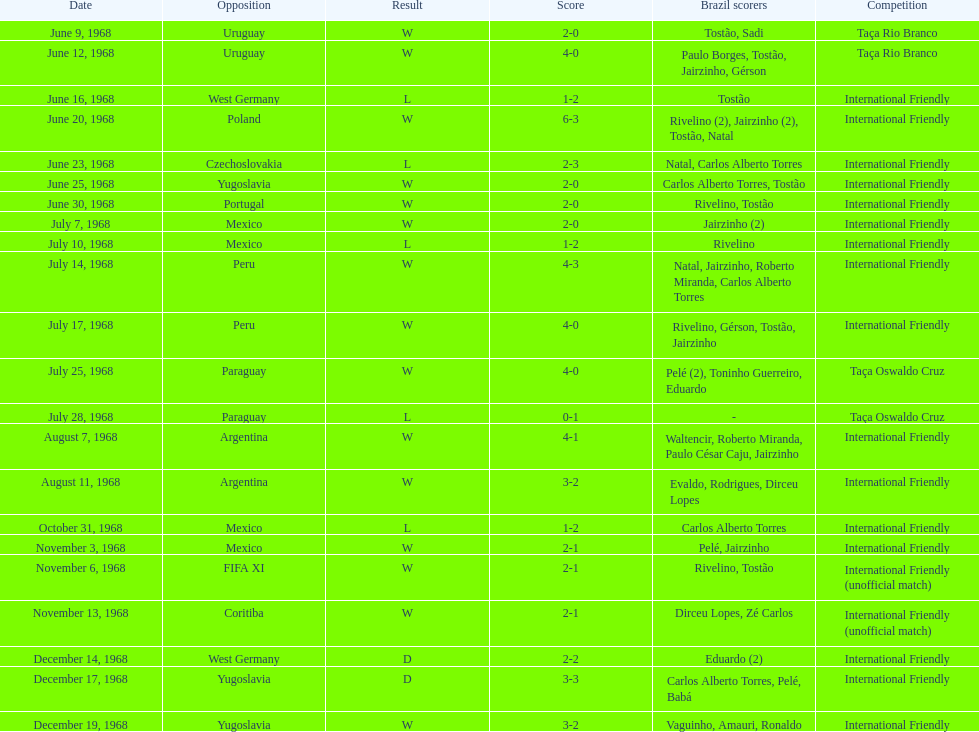Parse the table in full. {'header': ['Date', 'Opposition', 'Result', 'Score', 'Brazil scorers', 'Competition'], 'rows': [['June 9, 1968', 'Uruguay', 'W', '2-0', 'Tostão, Sadi', 'Taça Rio Branco'], ['June 12, 1968', 'Uruguay', 'W', '4-0', 'Paulo Borges, Tostão, Jairzinho, Gérson', 'Taça Rio Branco'], ['June 16, 1968', 'West Germany', 'L', '1-2', 'Tostão', 'International Friendly'], ['June 20, 1968', 'Poland', 'W', '6-3', 'Rivelino (2), Jairzinho (2), Tostão, Natal', 'International Friendly'], ['June 23, 1968', 'Czechoslovakia', 'L', '2-3', 'Natal, Carlos Alberto Torres', 'International Friendly'], ['June 25, 1968', 'Yugoslavia', 'W', '2-0', 'Carlos Alberto Torres, Tostão', 'International Friendly'], ['June 30, 1968', 'Portugal', 'W', '2-0', 'Rivelino, Tostão', 'International Friendly'], ['July 7, 1968', 'Mexico', 'W', '2-0', 'Jairzinho (2)', 'International Friendly'], ['July 10, 1968', 'Mexico', 'L', '1-2', 'Rivelino', 'International Friendly'], ['July 14, 1968', 'Peru', 'W', '4-3', 'Natal, Jairzinho, Roberto Miranda, Carlos Alberto Torres', 'International Friendly'], ['July 17, 1968', 'Peru', 'W', '4-0', 'Rivelino, Gérson, Tostão, Jairzinho', 'International Friendly'], ['July 25, 1968', 'Paraguay', 'W', '4-0', 'Pelé (2), Toninho Guerreiro, Eduardo', 'Taça Oswaldo Cruz'], ['July 28, 1968', 'Paraguay', 'L', '0-1', '-', 'Taça Oswaldo Cruz'], ['August 7, 1968', 'Argentina', 'W', '4-1', 'Waltencir, Roberto Miranda, Paulo César Caju, Jairzinho', 'International Friendly'], ['August 11, 1968', 'Argentina', 'W', '3-2', 'Evaldo, Rodrigues, Dirceu Lopes', 'International Friendly'], ['October 31, 1968', 'Mexico', 'L', '1-2', 'Carlos Alberto Torres', 'International Friendly'], ['November 3, 1968', 'Mexico', 'W', '2-1', 'Pelé, Jairzinho', 'International Friendly'], ['November 6, 1968', 'FIFA XI', 'W', '2-1', 'Rivelino, Tostão', 'International Friendly (unofficial match)'], ['November 13, 1968', 'Coritiba', 'W', '2-1', 'Dirceu Lopes, Zé Carlos', 'International Friendly (unofficial match)'], ['December 14, 1968', 'West Germany', 'D', '2-2', 'Eduardo (2)', 'International Friendly'], ['December 17, 1968', 'Yugoslavia', 'D', '3-3', 'Carlos Alberto Torres, Pelé, Babá', 'International Friendly'], ['December 19, 1968', 'Yugoslavia', 'W', '3-2', 'Vaguinho, Amauri, Ronaldo', 'International Friendly']]} How many times did brazil play against argentina in the international friendly competition? 2. 